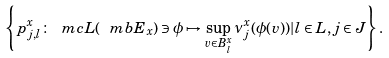<formula> <loc_0><loc_0><loc_500><loc_500>\left \{ p _ { j , l } ^ { x } \colon \ m c { L } ( \ m b { E } _ { x } ) \ni \phi \mapsto \sup _ { v \in B _ { l } ^ { x } } \nu _ { j } ^ { x } ( \phi ( v ) ) | l \in L , j \in J \right \} .</formula> 